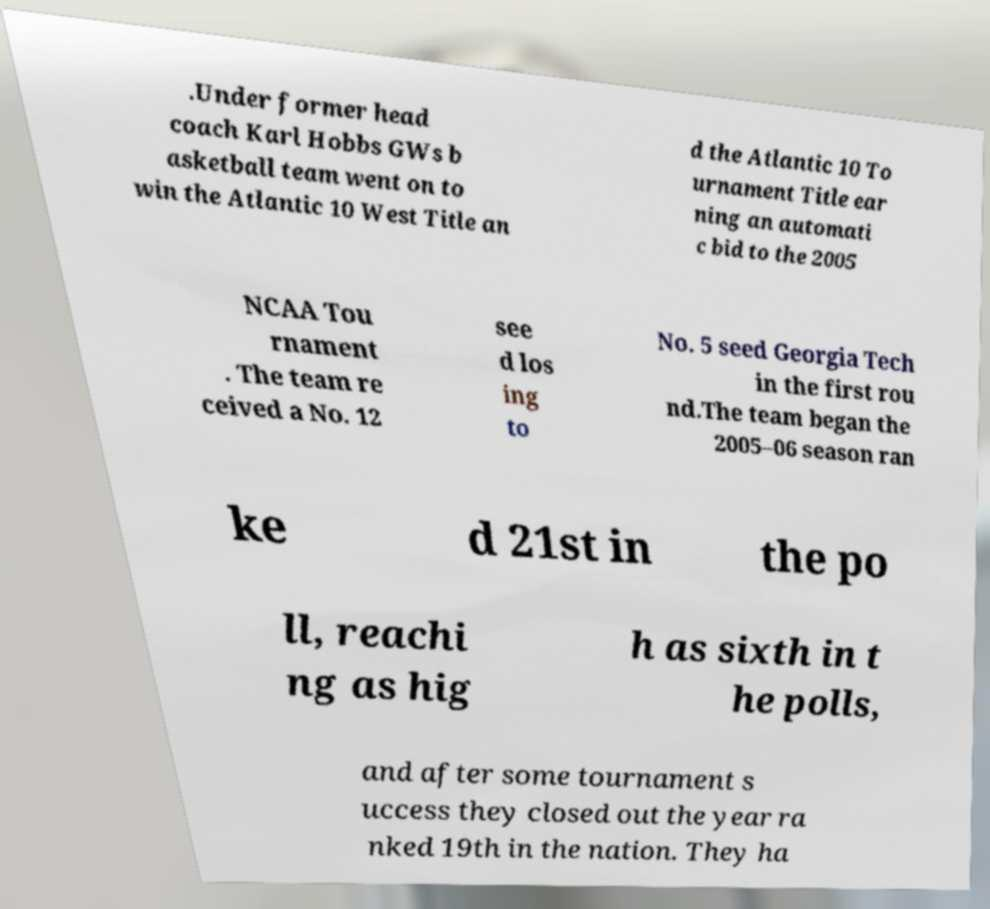Please read and relay the text visible in this image. What does it say? .Under former head coach Karl Hobbs GWs b asketball team went on to win the Atlantic 10 West Title an d the Atlantic 10 To urnament Title ear ning an automati c bid to the 2005 NCAA Tou rnament . The team re ceived a No. 12 see d los ing to No. 5 seed Georgia Tech in the first rou nd.The team began the 2005–06 season ran ke d 21st in the po ll, reachi ng as hig h as sixth in t he polls, and after some tournament s uccess they closed out the year ra nked 19th in the nation. They ha 